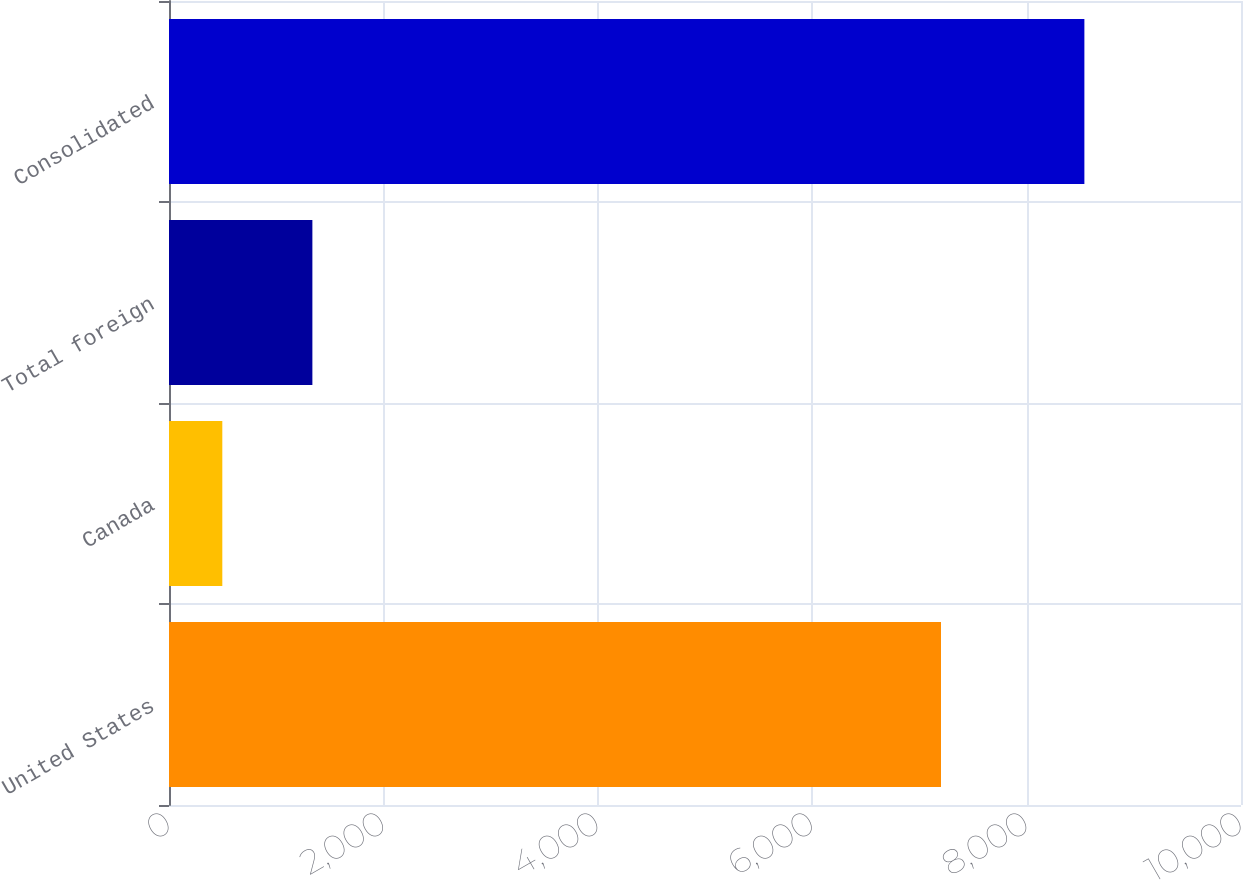<chart> <loc_0><loc_0><loc_500><loc_500><bar_chart><fcel>United States<fcel>Canada<fcel>Total foreign<fcel>Consolidated<nl><fcel>7201.5<fcel>497.3<fcel>1337.5<fcel>8539<nl></chart> 